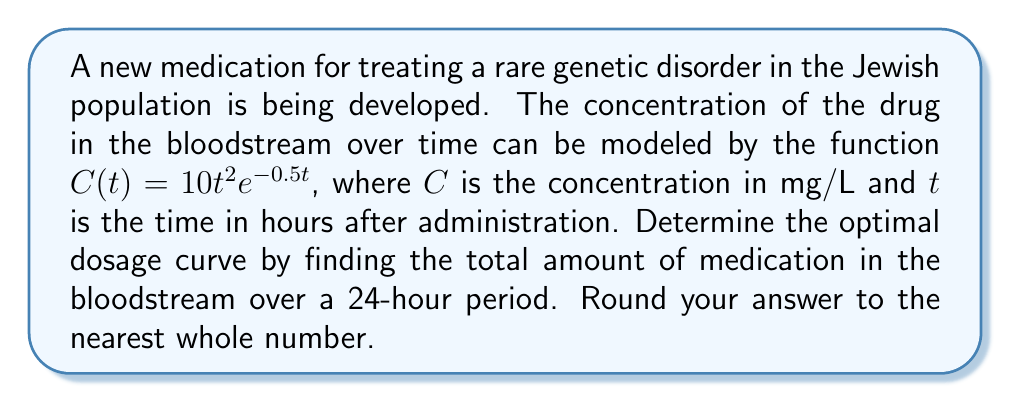Can you answer this question? To find the total amount of medication in the bloodstream over a 24-hour period, we need to integrate the concentration function $C(t)$ from 0 to 24 hours.

1) Set up the integral:
   $$\int_0^{24} C(t) dt = \int_0^{24} 10t^2e^{-0.5t} dt$$

2) This integral cannot be solved using elementary methods. We'll use integration by parts twice.

3) Let $u = t^2$ and $dv = e^{-0.5t}dt$
   Then $du = 2t dt$ and $v = -2e^{-0.5t}$

4) First integration by parts:
   $$\int t^2e^{-0.5t} dt = -2t^2e^{-0.5t} - \int (-2)(-2te^{-0.5t}) dt$$
   $$= -2t^2e^{-0.5t} + 4\int te^{-0.5t} dt$$

5) For the remaining integral, let $u = t$ and $dv = e^{-0.5t}dt$
   Then $du = dt$ and $v = -2e^{-0.5t}$

6) Second integration by parts:
   $$4\int te^{-0.5t} dt = 4(-2te^{-0.5t} - \int (-2)(e^{-0.5t}) dt)$$
   $$= -8te^{-0.5t} - 8\int e^{-0.5t} dt$$

7) Solve the final integral:
   $$-8\int e^{-0.5t} dt = 16e^{-0.5t} + C$$

8) Combine all terms:
   $$\int t^2e^{-0.5t} dt = -2t^2e^{-0.5t} - 8te^{-0.5t} + 16e^{-0.5t} + C$$

9) Multiply by 10 and evaluate from 0 to 24:
   $$10[-2t^2e^{-0.5t} - 8te^{-0.5t} + 16e^{-0.5t}]_0^{24}$$

10) Calculate the values:
    At t = 24: $10[-2(24^2)e^{-12} - 8(24)e^{-12} + 16e^{-12}] \approx -0.0000396$
    At t = 0: $10[0 - 0 + 16] = 160$

11) Subtract: 160 - (-0.0000396) ≈ 160 (rounded to nearest whole number)
Answer: 160 mg 